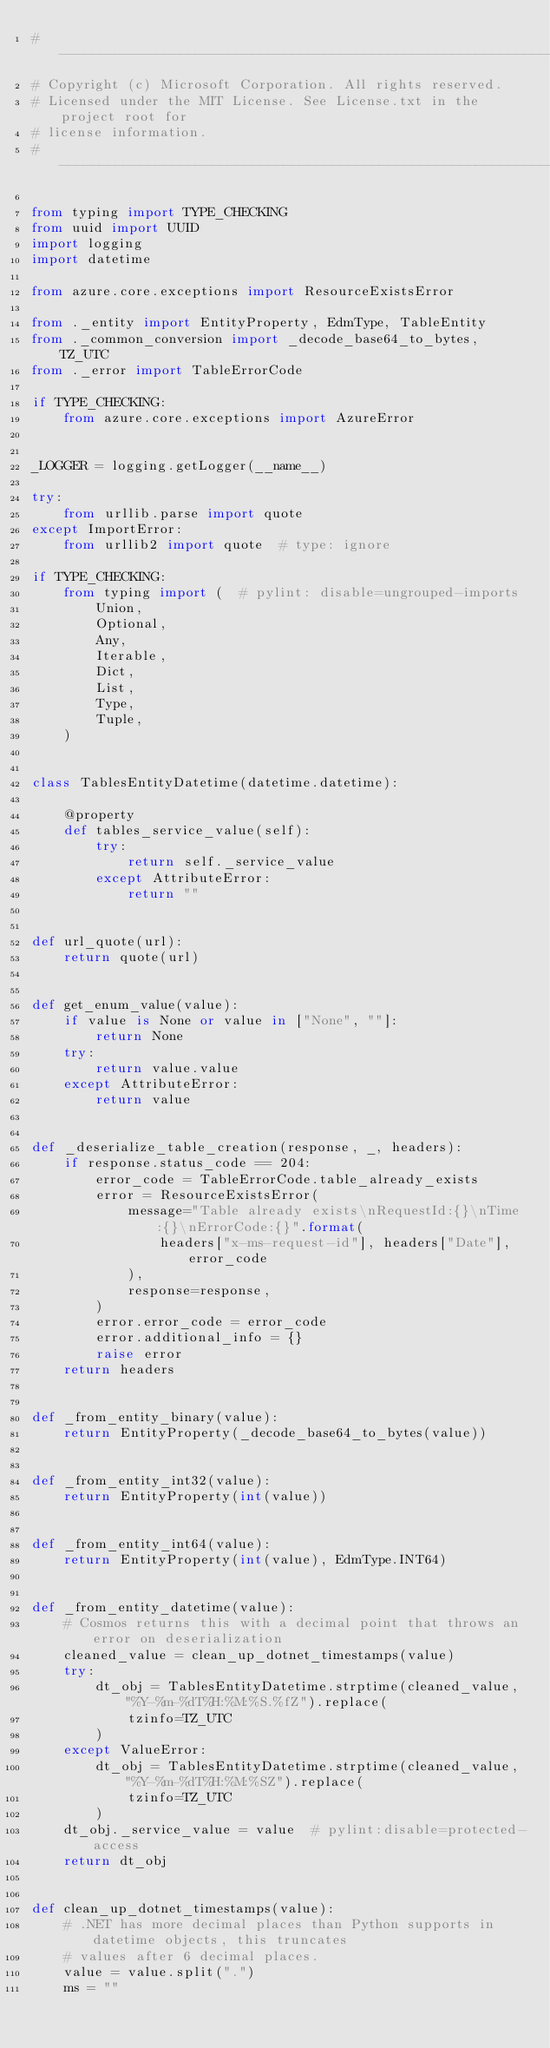Convert code to text. <code><loc_0><loc_0><loc_500><loc_500><_Python_># -------------------------------------------------------------------------
# Copyright (c) Microsoft Corporation. All rights reserved.
# Licensed under the MIT License. See License.txt in the project root for
# license information.
# --------------------------------------------------------------------------

from typing import TYPE_CHECKING
from uuid import UUID
import logging
import datetime

from azure.core.exceptions import ResourceExistsError

from ._entity import EntityProperty, EdmType, TableEntity
from ._common_conversion import _decode_base64_to_bytes, TZ_UTC
from ._error import TableErrorCode

if TYPE_CHECKING:
    from azure.core.exceptions import AzureError


_LOGGER = logging.getLogger(__name__)

try:
    from urllib.parse import quote
except ImportError:
    from urllib2 import quote  # type: ignore

if TYPE_CHECKING:
    from typing import (  # pylint: disable=ungrouped-imports
        Union,
        Optional,
        Any,
        Iterable,
        Dict,
        List,
        Type,
        Tuple,
    )


class TablesEntityDatetime(datetime.datetime):

    @property
    def tables_service_value(self):
        try:
            return self._service_value
        except AttributeError:
            return ""


def url_quote(url):
    return quote(url)


def get_enum_value(value):
    if value is None or value in ["None", ""]:
        return None
    try:
        return value.value
    except AttributeError:
        return value


def _deserialize_table_creation(response, _, headers):
    if response.status_code == 204:
        error_code = TableErrorCode.table_already_exists
        error = ResourceExistsError(
            message="Table already exists\nRequestId:{}\nTime:{}\nErrorCode:{}".format(
                headers["x-ms-request-id"], headers["Date"], error_code
            ),
            response=response,
        )
        error.error_code = error_code
        error.additional_info = {}
        raise error
    return headers


def _from_entity_binary(value):
    return EntityProperty(_decode_base64_to_bytes(value))


def _from_entity_int32(value):
    return EntityProperty(int(value))


def _from_entity_int64(value):
    return EntityProperty(int(value), EdmType.INT64)


def _from_entity_datetime(value):
    # Cosmos returns this with a decimal point that throws an error on deserialization
    cleaned_value = clean_up_dotnet_timestamps(value)
    try:
        dt_obj = TablesEntityDatetime.strptime(cleaned_value, "%Y-%m-%dT%H:%M:%S.%fZ").replace(
            tzinfo=TZ_UTC
        )
    except ValueError:
        dt_obj = TablesEntityDatetime.strptime(cleaned_value, "%Y-%m-%dT%H:%M:%SZ").replace(
            tzinfo=TZ_UTC
        )
    dt_obj._service_value = value  # pylint:disable=protected-access
    return dt_obj


def clean_up_dotnet_timestamps(value):
    # .NET has more decimal places than Python supports in datetime objects, this truncates
    # values after 6 decimal places.
    value = value.split(".")
    ms = ""</code> 